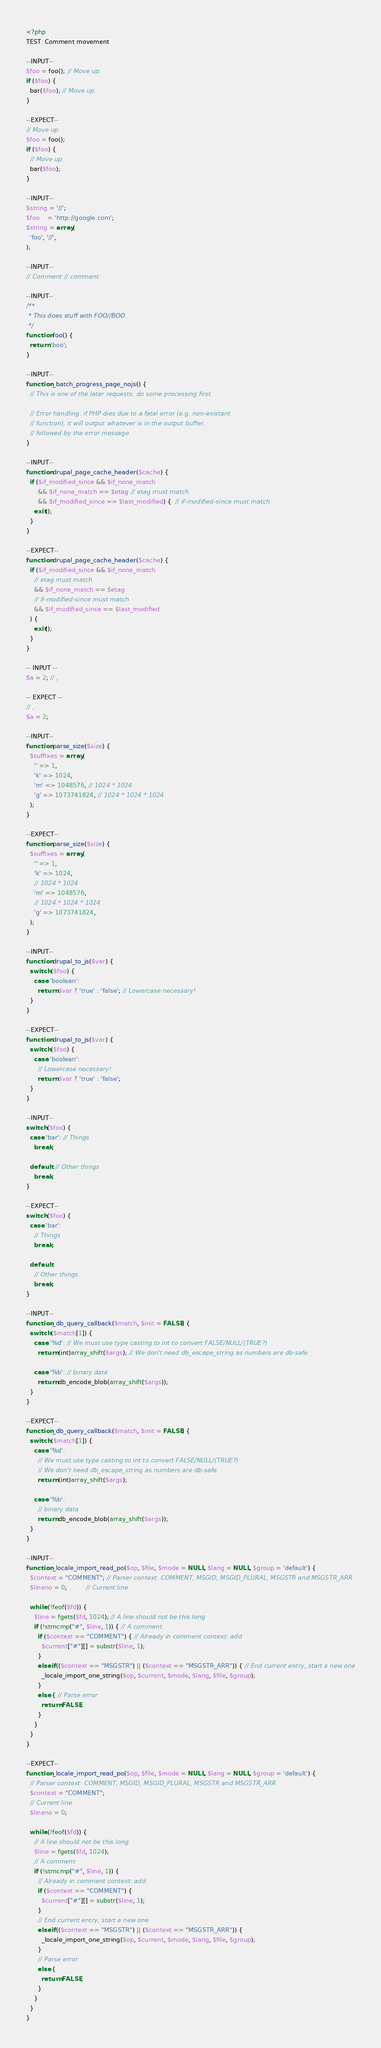<code> <loc_0><loc_0><loc_500><loc_500><_PHP_><?php
TEST: Comment movement

--INPUT--
$foo = foo(); // Move up.
if ($foo) {
  bar($foo); // Move up.
}

--EXPECT--
// Move up.
$foo = foo();
if ($foo) {
  // Move up.
  bar($foo);
}

--INPUT--
$string = '//';
$foo    = 'http://google.com';
$string = array(
  'foo', '//',
);

--INPUT--
// Comment // comment.

--INPUT--
/**
 * This does stuff with FOO//BOO.
 */
function foo() {
  return 'boo';
}

--INPUT--
function _batch_progress_page_nojs() {
  // This is one of the later requests: do some processing first.

  // Error handling: if PHP dies due to a fatal error (e.g. non-existant
  // function), it will output whatever is in the output buffer,
  // followed by the error message.
}

--INPUT--
function drupal_page_cache_header($cache) {
  if ($if_modified_since && $if_none_match
      && $if_none_match == $etag // etag must match
      && $if_modified_since == $last_modified) {  // if-modified-since must match
    exit();
  }
}

--EXPECT--
function drupal_page_cache_header($cache) {
  if ($if_modified_since && $if_none_match
    // etag must match
    && $if_none_match == $etag
    // if-modified-since must match
    && $if_modified_since == $last_modified
  ) {
    exit();
  }
}

-- INPUT --
$a = 2; // ,

-- EXPECT --
// ,
$a = 2;

--INPUT--
function parse_size($size) {
  $suffixes = array(
    '' => 1,
    'k' => 1024,
    'm' => 1048576, // 1024 * 1024
    'g' => 1073741824, // 1024 * 1024 * 1024
  );
}

--EXPECT--
function parse_size($size) {
  $suffixes = array(
    '' => 1,
    'k' => 1024,
    // 1024 * 1024
    'm' => 1048576,
    // 1024 * 1024 * 1024
    'g' => 1073741824,
  );
}

--INPUT--
function drupal_to_js($var) {
  switch ($foo) {
    case 'boolean':
      return $var ? 'true' : 'false'; // Lowercase necessary!
  }
}

--EXPECT--
function drupal_to_js($var) {
  switch ($foo) {
    case 'boolean':
      // Lowercase necessary!
      return $var ? 'true' : 'false';
  }
}

--INPUT--
switch ($foo) {
  case 'bar': // Things
    break;

  default: // Other things
    break;
}

--EXPECT--
switch ($foo) {
  case 'bar':
    // Things
    break;

  default:
    // Other things
    break;
}

--INPUT--
function _db_query_callback($match, $init = FALSE) {
  switch ($match[1]) {
    case '%d': // We must use type casting to int to convert FALSE/NULL/(TRUE?)
      return (int)array_shift($args); // We don't need db_escape_string as numbers are db-safe

    case '%b': // binary data
      return db_encode_blob(array_shift($args));
  }
}

--EXPECT--
function _db_query_callback($match, $init = FALSE) {
  switch ($match[1]) {
    case '%d':
      // We must use type casting to int to convert FALSE/NULL/(TRUE?)
      // We don't need db_escape_string as numbers are db-safe
      return (int)array_shift($args);

    case '%b':
      // binary data
      return db_encode_blob(array_shift($args));
  }
}

--INPUT--
function _locale_import_read_po($op, $file, $mode = NULL, $lang = NULL, $group = 'default') {
  $context = "COMMENT"; // Parser context: COMMENT, MSGID, MSGID_PLURAL, MSGSTR and MSGSTR_ARR
  $lineno = 0;          // Current line

  while (!feof($fd)) {
    $line = fgets($fd, 1024); // A line should not be this long
    if (!strncmp("#", $line, 1)) { // A comment
      if ($context == "COMMENT") { // Already in comment context: add
        $current["#"][] = substr($line, 1);
      }
      elseif (($context == "MSGSTR") || ($context == "MSGSTR_ARR")) { // End current entry, start a new one
        _locale_import_one_string($op, $current, $mode, $lang, $file, $group);
      }
      else { // Parse error
        return FALSE;
      }
    }
  }
}

--EXPECT--
function _locale_import_read_po($op, $file, $mode = NULL, $lang = NULL, $group = 'default') {
  // Parser context: COMMENT, MSGID, MSGID_PLURAL, MSGSTR and MSGSTR_ARR
  $context = "COMMENT";
  // Current line
  $lineno = 0;

  while (!feof($fd)) {
    // A line should not be this long
    $line = fgets($fd, 1024);
    // A comment
    if (!strncmp("#", $line, 1)) {
      // Already in comment context: add
      if ($context == "COMMENT") {
        $current["#"][] = substr($line, 1);
      }
      // End current entry, start a new one
      elseif (($context == "MSGSTR") || ($context == "MSGSTR_ARR")) {
        _locale_import_one_string($op, $current, $mode, $lang, $file, $group);
      }
      // Parse error
      else {
        return FALSE;
      }
    }
  }
}

</code> 